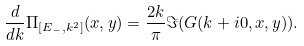<formula> <loc_0><loc_0><loc_500><loc_500>\frac { d } { d k } \Pi _ { [ E _ { - } , k ^ { 2 } ] } ( x , y ) = \frac { 2 k } { \pi } \Im ( G ( k + i 0 , x , y ) ) .</formula> 